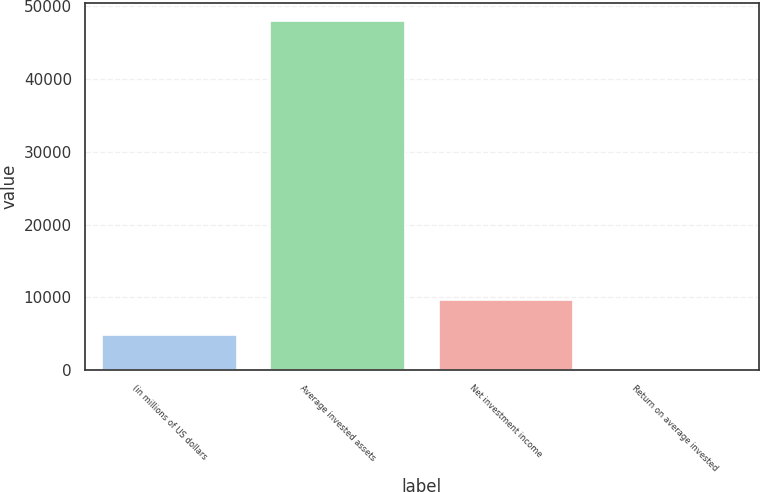Convert chart to OTSL. <chart><loc_0><loc_0><loc_500><loc_500><bar_chart><fcel>(in millions of US dollars<fcel>Average invested assets<fcel>Net investment income<fcel>Return on average invested<nl><fcel>4808.27<fcel>48044<fcel>9612.24<fcel>4.3<nl></chart> 